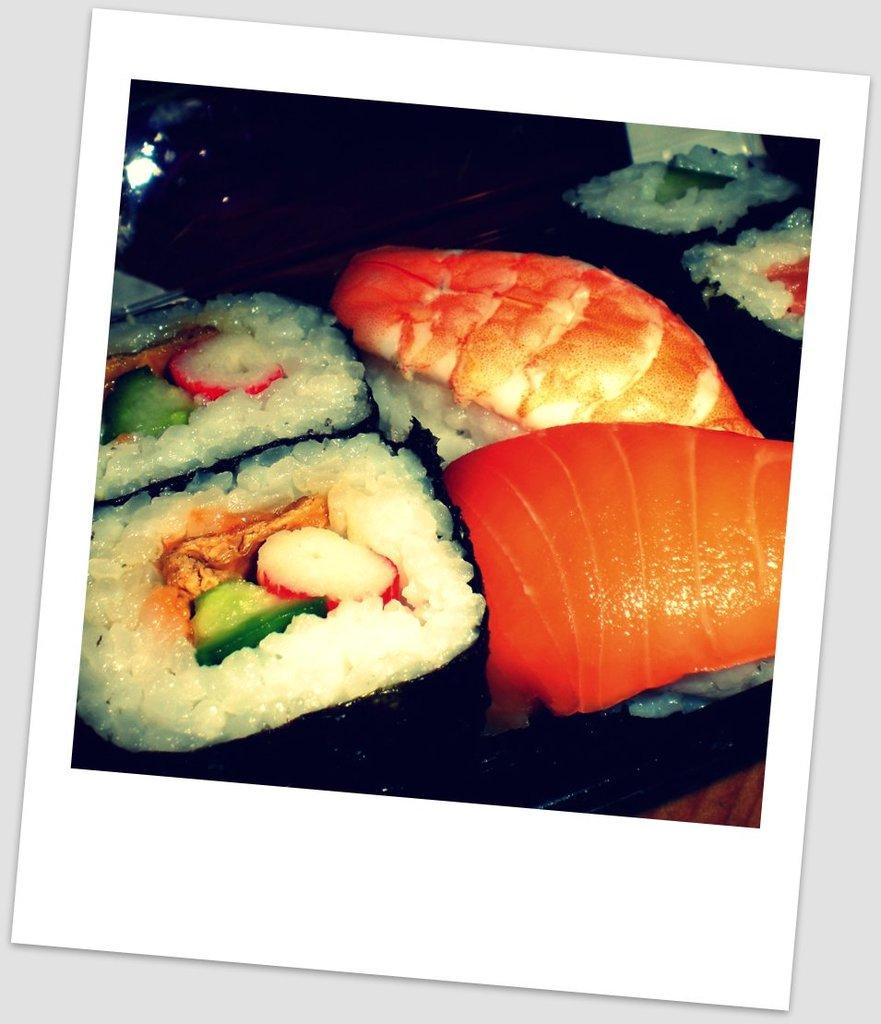What is the main object in the image? There is a Polaroid photo in the image. What can be seen in the Polaroid photo? The photo contains an image of food. What type of brass instrument is being played in the image? There is no brass instrument present in the image; it only contains a Polaroid photo with an image of food. 